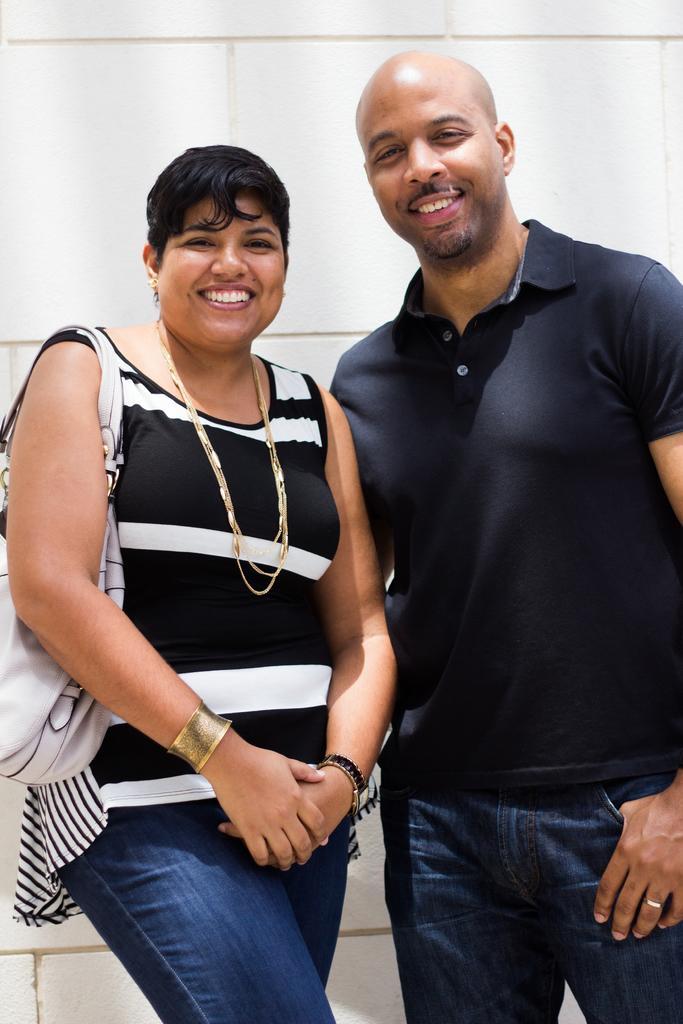In one or two sentences, can you explain what this image depicts? In this image we can see a man and woman is standing and smiling. Man is wearing black t-shirt with jeans and the woman is wearing black and white top with jeans and she is holding white color bag. 